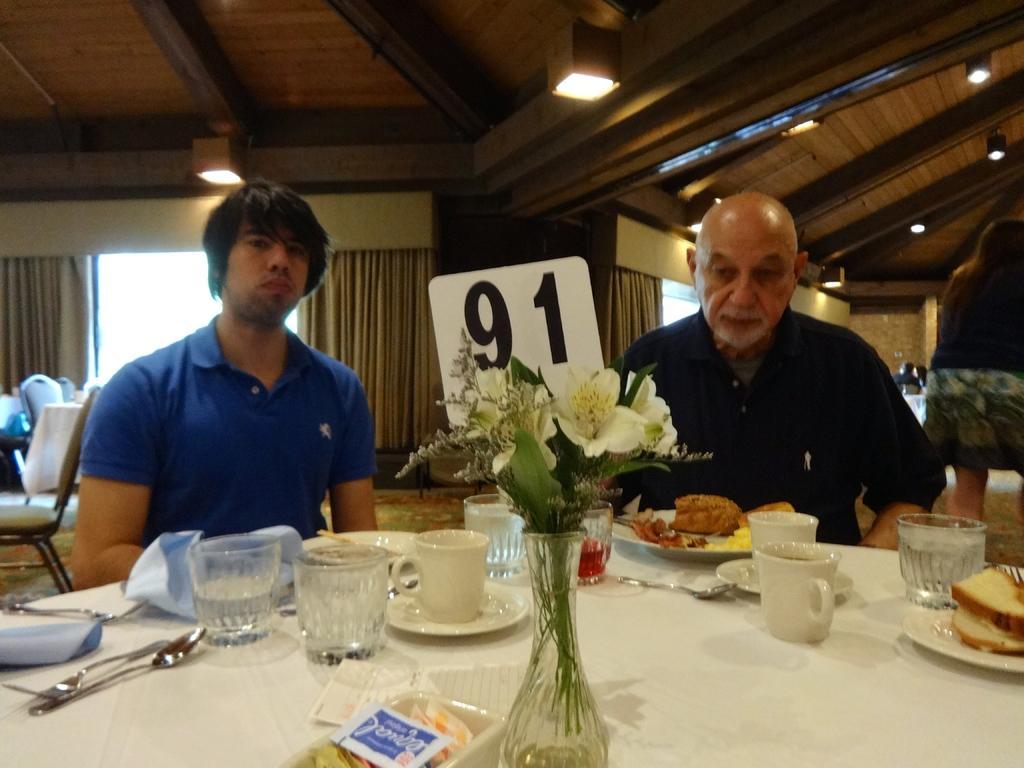Could you give a brief overview of what you see in this image? Here we can see a two persons sitting on a chair and they are having a food. This is a table where a flower vase, a cup, a glass, a spoon and a plate are kept on it. In the background we can see a glass window and a curtain. 